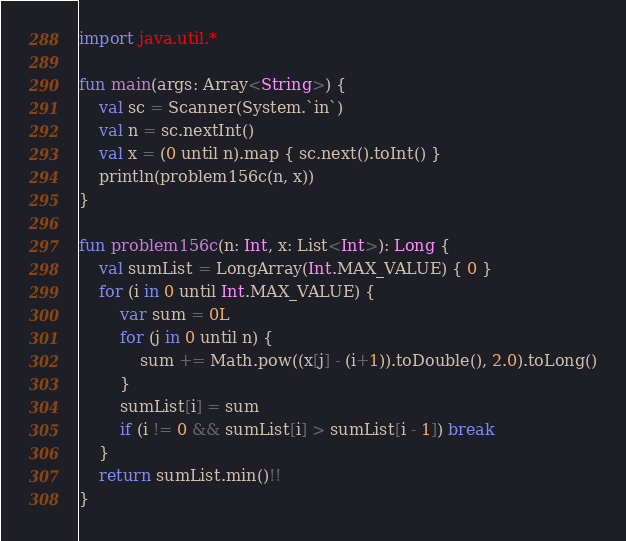Convert code to text. <code><loc_0><loc_0><loc_500><loc_500><_Kotlin_>import java.util.*

fun main(args: Array<String>) {
    val sc = Scanner(System.`in`)
    val n = sc.nextInt()
    val x = (0 until n).map { sc.next().toInt() }
    println(problem156c(n, x))
}

fun problem156c(n: Int, x: List<Int>): Long {
    val sumList = LongArray(Int.MAX_VALUE) { 0 }
    for (i in 0 until Int.MAX_VALUE) {
        var sum = 0L
        for (j in 0 until n) {
            sum += Math.pow((x[j] - (i+1)).toDouble(), 2.0).toLong()
        }
        sumList[i] = sum
        if (i != 0 && sumList[i] > sumList[i - 1]) break
    }
    return sumList.min()!!
}</code> 